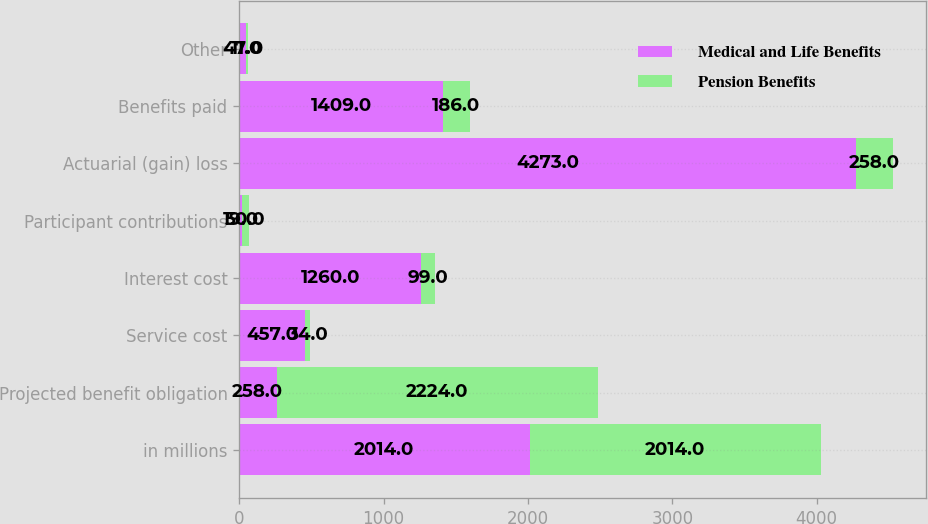Convert chart. <chart><loc_0><loc_0><loc_500><loc_500><stacked_bar_chart><ecel><fcel>in millions<fcel>Projected benefit obligation<fcel>Service cost<fcel>Interest cost<fcel>Participant contributions<fcel>Actuarial (gain) loss<fcel>Benefits paid<fcel>Other<nl><fcel>Medical and Life Benefits<fcel>2014<fcel>258<fcel>457<fcel>1260<fcel>19<fcel>4273<fcel>1409<fcel>47<nl><fcel>Pension Benefits<fcel>2014<fcel>2224<fcel>34<fcel>99<fcel>50<fcel>258<fcel>186<fcel>11<nl></chart> 